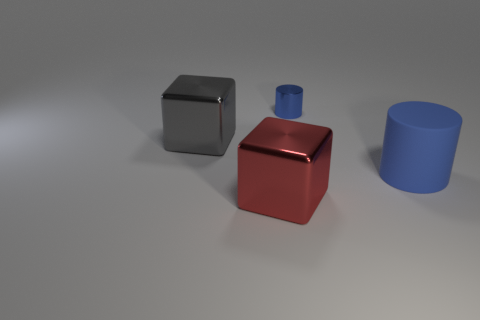Add 4 blue cylinders. How many objects exist? 8 Subtract 1 cylinders. How many cylinders are left? 1 Add 3 large matte objects. How many large matte objects are left? 4 Add 1 tiny blue cylinders. How many tiny blue cylinders exist? 2 Subtract 1 gray cubes. How many objects are left? 3 Subtract all yellow blocks. Subtract all cyan cylinders. How many blocks are left? 2 Subtract all gray metal objects. Subtract all big red things. How many objects are left? 2 